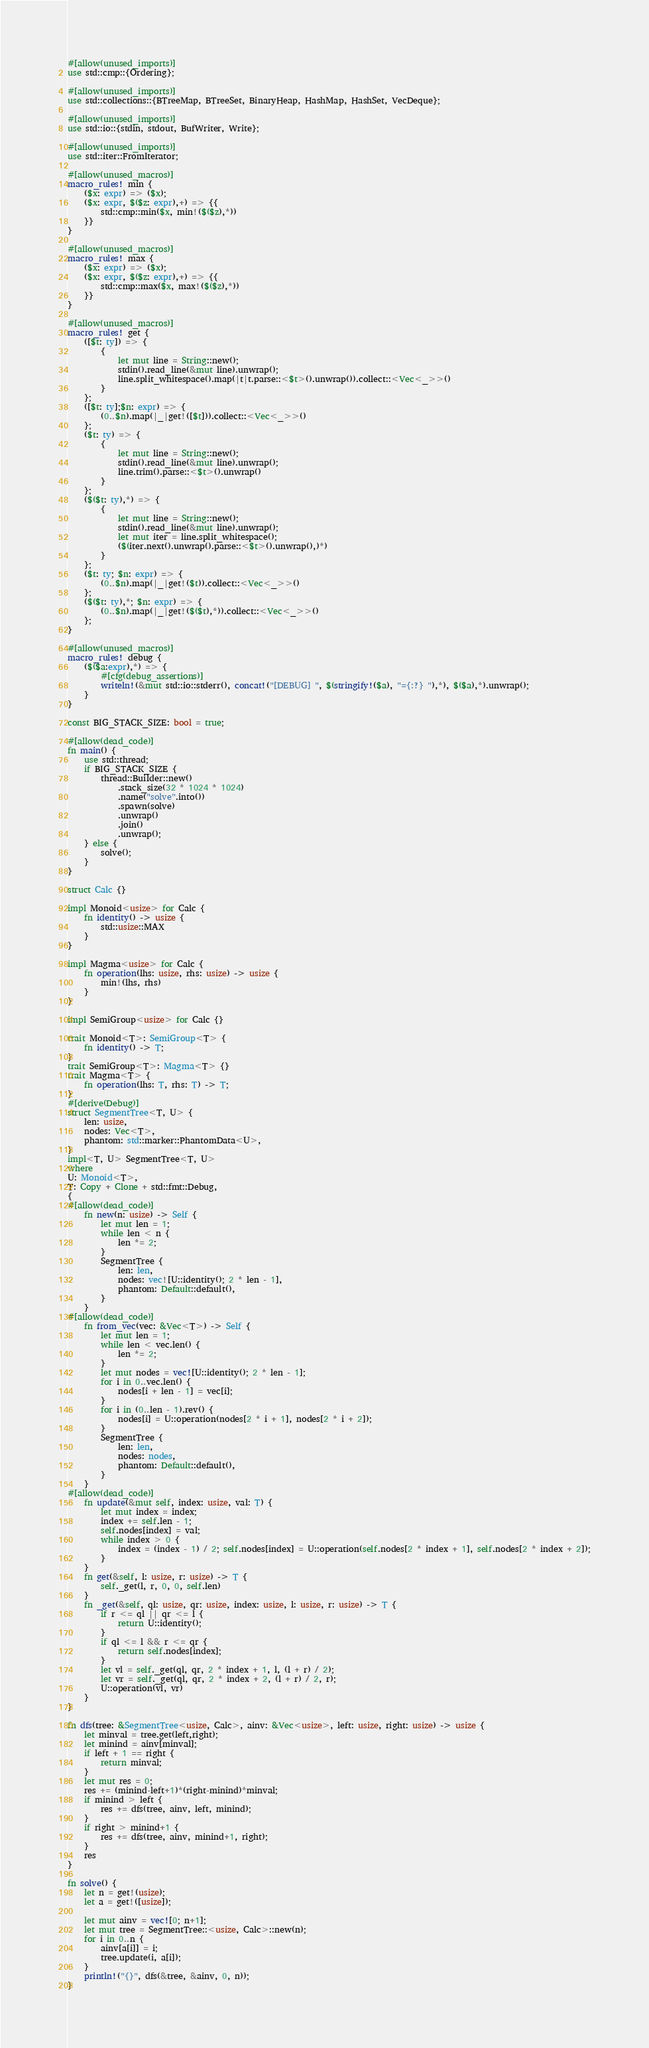<code> <loc_0><loc_0><loc_500><loc_500><_Rust_>#[allow(unused_imports)]
use std::cmp::{Ordering};

#[allow(unused_imports)]
use std::collections::{BTreeMap, BTreeSet, BinaryHeap, HashMap, HashSet, VecDeque};

#[allow(unused_imports)]
use std::io::{stdin, stdout, BufWriter, Write};

#[allow(unused_imports)]
use std::iter::FromIterator;

#[allow(unused_macros)]
macro_rules! min {
    ($x: expr) => ($x);
    ($x: expr, $($z: expr),+) => {{
        std::cmp::min($x, min!($($z),*))
    }}
}

#[allow(unused_macros)]
macro_rules! max {
    ($x: expr) => ($x);
    ($x: expr, $($z: expr),+) => {{
        std::cmp::max($x, max!($($z),*))
    }}
}

#[allow(unused_macros)]
macro_rules! get { 
    ([$t: ty]) => { 
        { 
            let mut line = String::new(); 
            stdin().read_line(&mut line).unwrap(); 
            line.split_whitespace().map(|t|t.parse::<$t>().unwrap()).collect::<Vec<_>>()
        }
    };
    ([$t: ty];$n: expr) => {
        (0..$n).map(|_|get!([$t])).collect::<Vec<_>>()
    };
    ($t: ty) => {
        {
            let mut line = String::new();
            stdin().read_line(&mut line).unwrap();
            line.trim().parse::<$t>().unwrap()
        }
    };
    ($($t: ty),*) => {
        { 
            let mut line = String::new();
            stdin().read_line(&mut line).unwrap();
            let mut iter = line.split_whitespace();
            ($(iter.next().unwrap().parse::<$t>().unwrap(),)*)
        }
    };
    ($t: ty; $n: expr) => {
        (0..$n).map(|_|get!($t)).collect::<Vec<_>>()
    };
    ($($t: ty),*; $n: expr) => {
        (0..$n).map(|_|get!($($t),*)).collect::<Vec<_>>()
    };
}

#[allow(unused_macros)]
macro_rules! debug {
    ($($a:expr),*) => {
        #[cfg(debug_assertions)]
        writeln!(&mut std::io::stderr(), concat!("[DEBUG] ", $(stringify!($a), "={:?} "),*), $($a),*).unwrap();
    }
}

const BIG_STACK_SIZE: bool = true;

#[allow(dead_code)]
fn main() {
    use std::thread;
    if BIG_STACK_SIZE {
        thread::Builder::new()
            .stack_size(32 * 1024 * 1024)
            .name("solve".into())
            .spawn(solve)
            .unwrap()
            .join()
            .unwrap();
    } else {
        solve();
    }
}

struct Calc {}

impl Monoid<usize> for Calc {
    fn identity() -> usize {
        std::usize::MAX
    }
}

impl Magma<usize> for Calc {
    fn operation(lhs: usize, rhs: usize) -> usize {
        min!(lhs, rhs)
    }
}

impl SemiGroup<usize> for Calc {}

trait Monoid<T>: SemiGroup<T> {
    fn identity() -> T;
}
trait SemiGroup<T>: Magma<T> {}
trait Magma<T> {
    fn operation(lhs: T, rhs: T) -> T;
}
#[derive(Debug)]
struct SegmentTree<T, U> {
    len: usize,
    nodes: Vec<T>,
    phantom: std::marker::PhantomData<U>,
}
impl<T, U> SegmentTree<T, U>
where
U: Monoid<T>,
T: Copy + Clone + std::fmt::Debug,
{
#[allow(dead_code)]
    fn new(n: usize) -> Self {
        let mut len = 1;
        while len < n {
            len *= 2;
        }
        SegmentTree {
            len: len,
            nodes: vec![U::identity(); 2 * len - 1],
            phantom: Default::default(),
        }
    }
#[allow(dead_code)]
    fn from_vec(vec: &Vec<T>) -> Self {
        let mut len = 1;
        while len < vec.len() {
            len *= 2;
        }
        let mut nodes = vec![U::identity(); 2 * len - 1];
        for i in 0..vec.len() {
            nodes[i + len - 1] = vec[i];
        }
        for i in (0..len - 1).rev() {
            nodes[i] = U::operation(nodes[2 * i + 1], nodes[2 * i + 2]);
        }
        SegmentTree {
            len: len,
            nodes: nodes,
            phantom: Default::default(),
        }
    }
#[allow(dead_code)]
    fn update(&mut self, index: usize, val: T) {
        let mut index = index;
        index += self.len - 1;
        self.nodes[index] = val;
        while index > 0 {
            index = (index - 1) / 2; self.nodes[index] = U::operation(self.nodes[2 * index + 1], self.nodes[2 * index + 2]);
        }
    }
    fn get(&self, l: usize, r: usize) -> T {
        self._get(l, r, 0, 0, self.len)
    }
    fn _get(&self, ql: usize, qr: usize, index: usize, l: usize, r: usize) -> T {
        if r <= ql || qr <= l {
            return U::identity();
        }
        if ql <= l && r <= qr {
            return self.nodes[index];
        }
        let vl = self._get(ql, qr, 2 * index + 1, l, (l + r) / 2);
        let vr = self._get(ql, qr, 2 * index + 2, (l + r) / 2, r);
        U::operation(vl, vr)
    }
}

fn dfs(tree: &SegmentTree<usize, Calc>, ainv: &Vec<usize>, left: usize, right: usize) -> usize {
    let minval = tree.get(left,right);
    let minind = ainv[minval];
    if left + 1 == right {
        return minval;
    }
    let mut res = 0;
    res += (minind-left+1)*(right-minind)*minval;
    if minind > left {
        res += dfs(tree, ainv, left, minind);
    }
    if right > minind+1 {
        res += dfs(tree, ainv, minind+1, right);
    }
    res
}

fn solve() {
    let n = get!(usize);
    let a = get!([usize]);

    let mut ainv = vec![0; n+1];
    let mut tree = SegmentTree::<usize, Calc>::new(n);
    for i in 0..n {
        ainv[a[i]] = i;
        tree.update(i, a[i]);
    }
    println!("{}", dfs(&tree, &ainv, 0, n));
}
</code> 